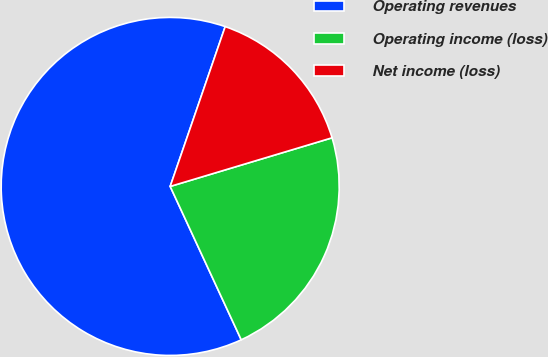Convert chart. <chart><loc_0><loc_0><loc_500><loc_500><pie_chart><fcel>Operating revenues<fcel>Operating income (loss)<fcel>Net income (loss)<nl><fcel>62.18%<fcel>22.74%<fcel>15.08%<nl></chart> 